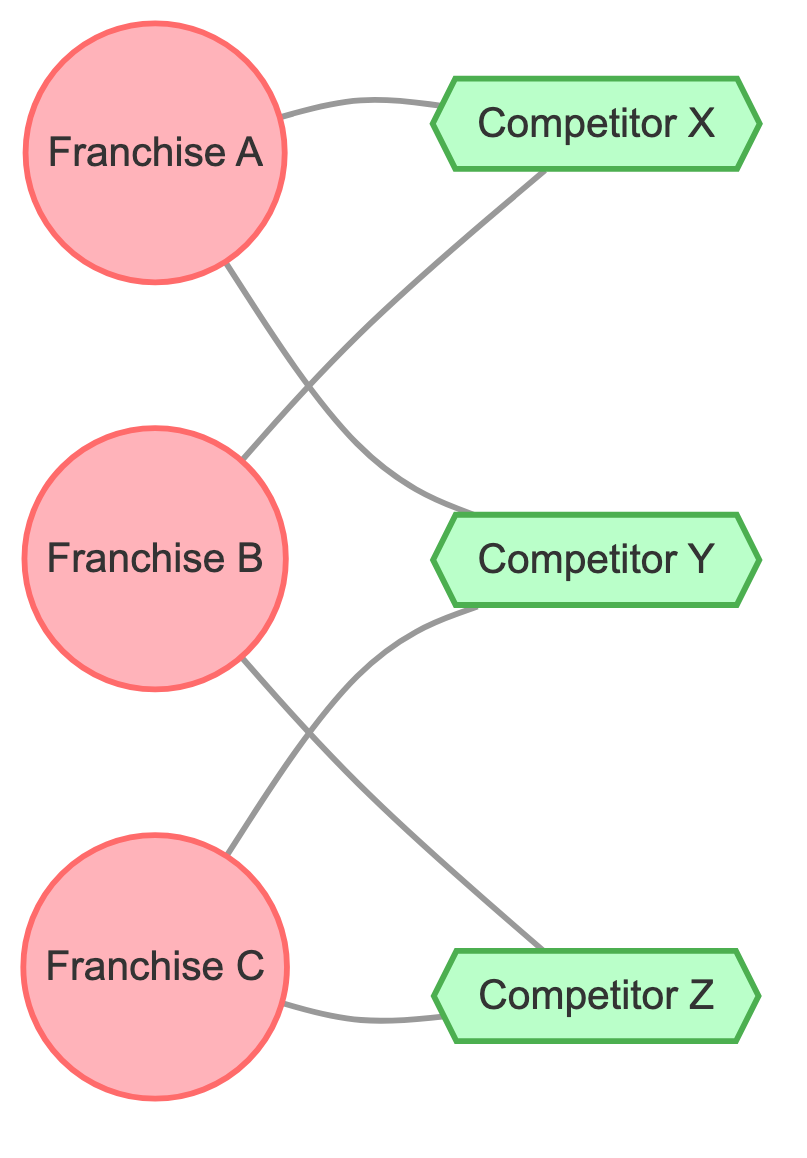What franchises share Competitor X? From the diagram, we can see that both Franchise A and Franchise B have edges connecting them to Competitor X. This means that they share Competitor X.
Answer: Franchise A, Franchise B How many competitors are connected to Franchise B? By examining the edges connected to Franchise B, we see that it has two edges going out: one to Competitor X and one to Competitor Z. Therefore, the number of competitors connected to Franchise B is two.
Answer: 2 Which competitor is shared by both Franchise C and Franchise A? Looking at the edges connected to Franchise C and Franchise A, we can identify Competitor Y connected to Franchise A and also to Franchise C. This indicates that they share Competitor Y.
Answer: Competitor Y What is the total number of nodes in the diagram? The nodes consist of three franchises and three competitors, adding up to a total of six nodes in the diagram.
Answer: 6 Which franchise has the most competitors? By analyzing the edges, Franchise A is connected to Competitor X and Competitor Y (two competitors), while Franchise B is also connected to Competitor X and Competitor Z (two competitors), and Franchise C is connected to Competitor Y and Competitor Z (two competitors). Since all franchises have the same number of competitors, none has more than the others.
Answer: None Which competitor is exclusively linked to Franchise A? Reviewing the edges in the diagram reveals that both competitors linked to Franchise A (Competitor X and Competitor Y) are also connected to other franchises, indicating that there is no competitor that is exclusively linked to Franchise A alone.
Answer: None How many total edges are present in the graph? By counting the connections (edges) from the franchises to their competitors in the diagram, we find that there are six edges total leading from the three franchises to the three competitors.
Answer: 6 What franchise connects to Competitor Z? Observing the edges in the diagram, Franchise B connects to Competitor Z, as well as Franchise C. Thus, the franchises connecting to Competitor Z include both of these franchises.
Answer: Franchise B, Franchise C Which competitor has the most connections in this graph? Analyzing the edges, we find that Competitor Y is connected to Franchise A and Franchise C, and Competitor Z is connected to Franchise B and Franchise C. However, the maximum connections are tied, as both Competitor Y and Competitor Z have two connections.
Answer: Neither 